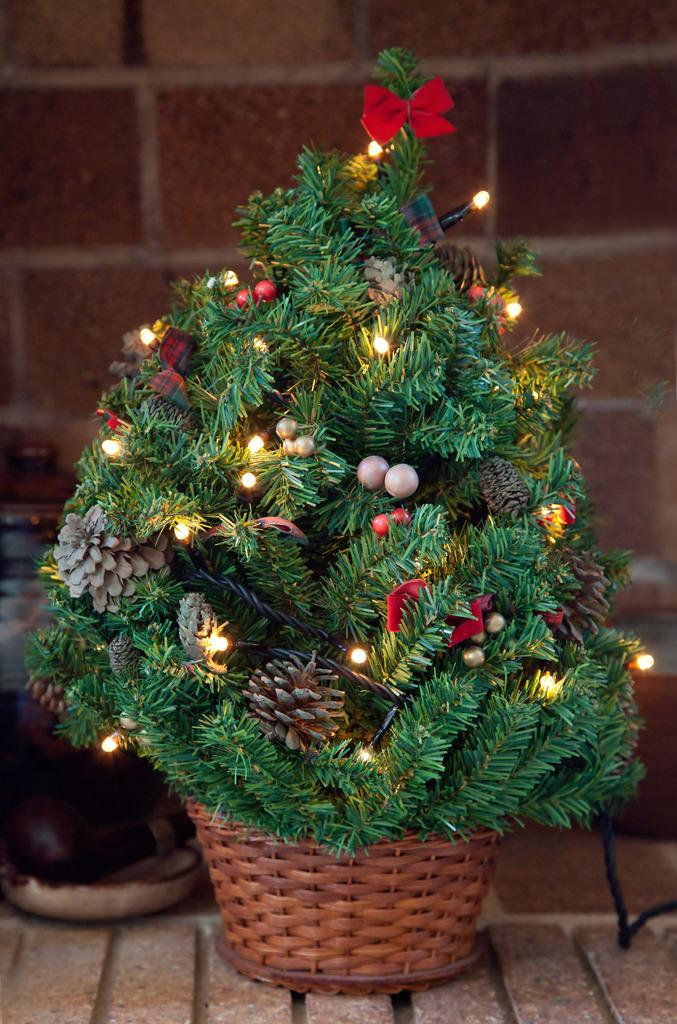What is located in the image that can hold items? There is a basket in the image. What is placed inside the basket? A plant is on the basket. Are there any additional features on the plant? Yes, there are lights on the plant. What can be seen in the background of the image? There is a wall in the background of the image. What is the unidentified object on the left bottom of the image? Unfortunately, the facts provided do not give enough information to describe the unidentified object. What type of silver collar is the plant wearing in the image? There is no silver collar present on the plant in the image. 